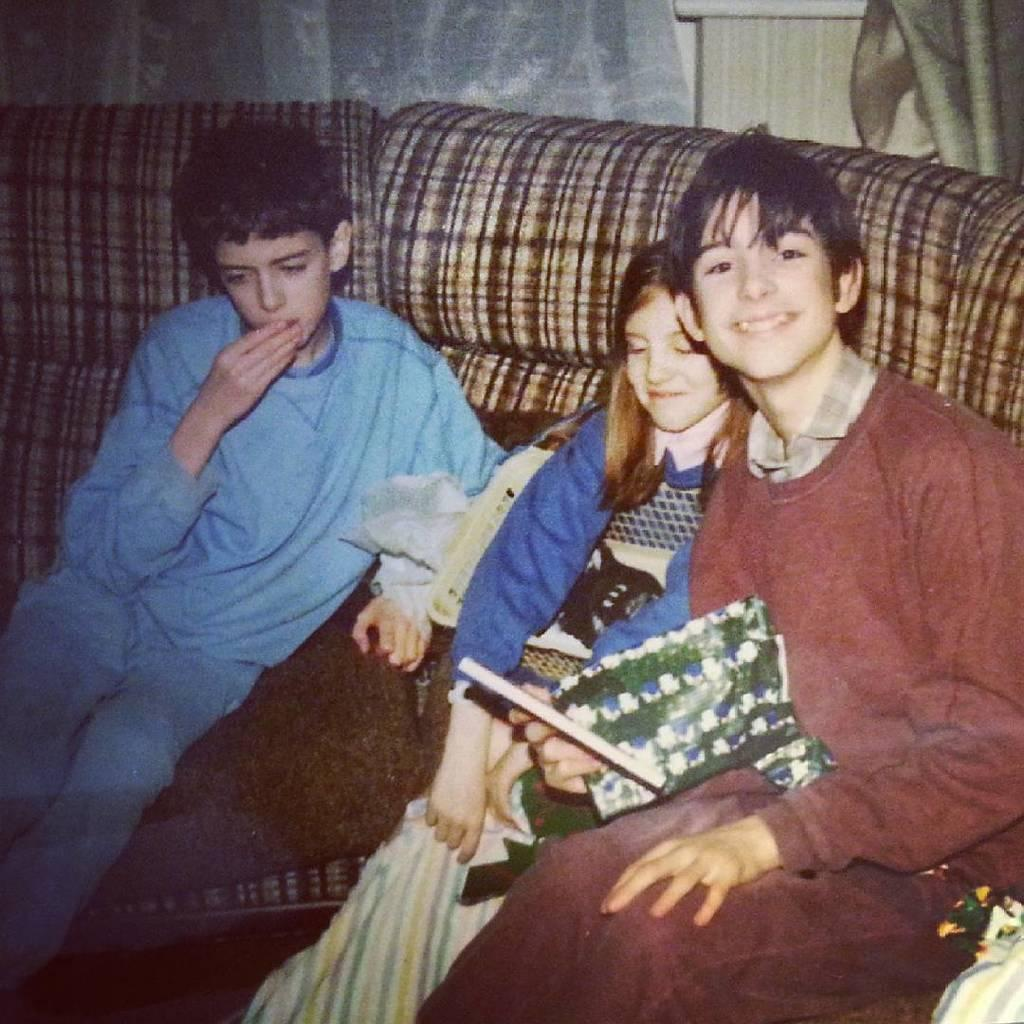Who is present in the image? There are kids in the image. What are the kids doing in the image? The kids are sitting on a sofa. What can be seen in the background of the image? There is a curtain in the background of the image. What type of berry is being taught by the minister in the image? There is no minister or berry present in the image; it features kids sitting on a sofa with a curtain in the background. 